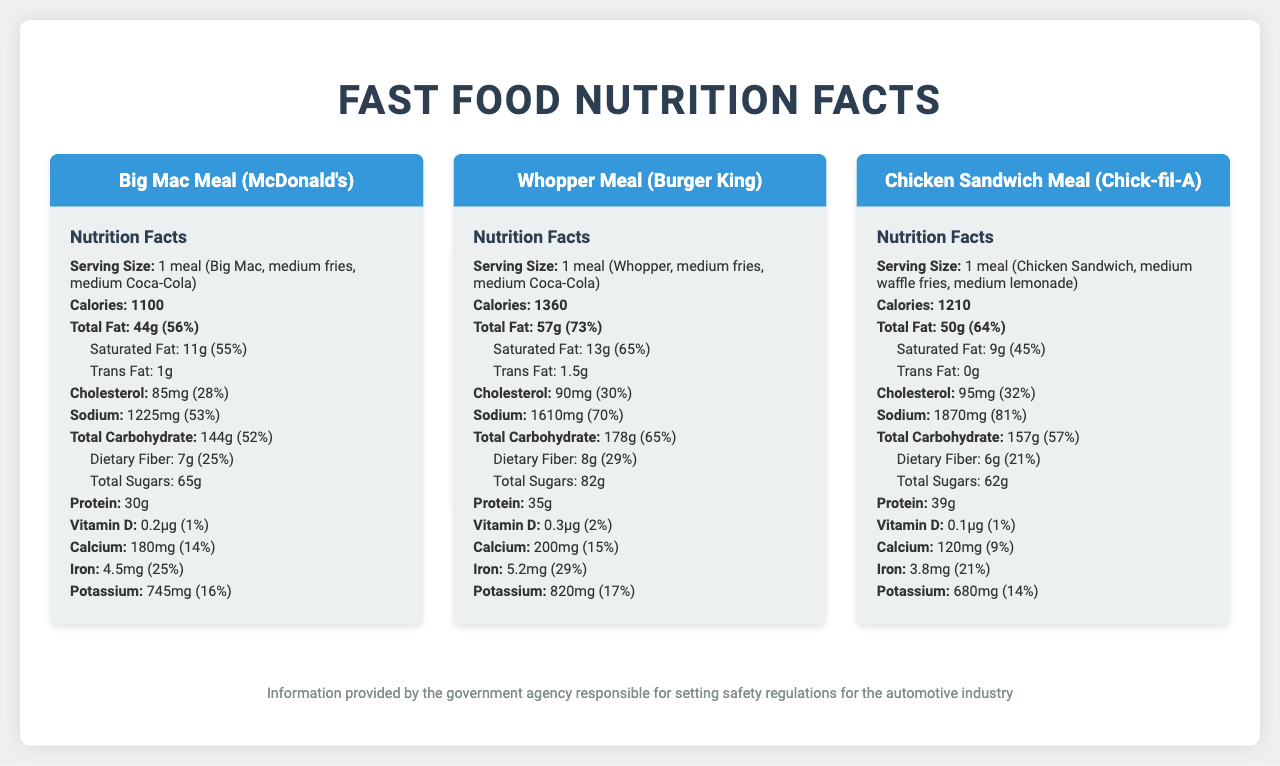what is the total calorie count for the Big Mac Meal? The document lists the calorie count for the Big Mac Meal as 1100 calories under the "Calories" section.
Answer: 1100 calories which meal has the highest total fat content? A. Big Mac Meal B. Whopper Meal C. Chicken Sandwich Meal The Whopper Meal has the highest total fat content of 57 grams, as stated in the document under the “Total Fat” section.
Answer: B what is the daily value percentage of saturated fat in the Chicken Sandwich Meal? The document specifies that the Chicken Sandwich Meal contains 9 grams of saturated fat, which is 45% of the daily value.
Answer: 45% how much dietary fiber is in the Whopper Meal? The document states that the Whopper Meal contains 8 grams of dietary fiber.
Answer: 8 grams which meal provides the most protein? According to the document, the Chicken Sandwich Meal provides 39 grams of protein, the highest among the listed meals.
Answer: Chicken Sandwich Meal how much calcium is provided by the Big Mac Meal? The document indicates that the Big Mac Meal contains 180 milligrams of calcium.
Answer: 180 mg does the document include information about organic ingredients? There is no mention or indication of organic ingredients in the document.
Answer: No summarize the main nutritional concerns for the meals listed in the document The document focuses on the nutritional breakdown of popular fast-food meals, highlighting high calorie counts, high sodium levels, and significant amounts of total fat and saturated fat.
Answer: High calories, high sodium, and significant total and saturated fat content compare the sodium content in the Big Mac Meal and the Chicken Sandwich Meal The Chicken Sandwich Meal contains 1870 milligrams of sodium compared to 1225 milligrams in the Big Mac Meal.
Answer: Chicken Sandwich Meal has more sodium which fast food meal has the highest sugar content? A. Big Mac Meal B. Whopper Meal C. Chicken Sandwich Meal D. Not enough information The Whopper Meal has the highest sugar content with 82 grams, according to the document.
Answer: B how many grams of trans fat are in the Whopper Meal? The document lists 1.5 grams of trans fat for the Whopper Meal under the “Trans Fat” section.
Answer: 1.5 grams how does the vitamin D content compare among the meals? The Whopper Meal provides 0.3 micrograms of vitamin D, more than the Big Mac Meal (0.2 micrograms) and the Chicken Sandwich Meal (0.1 micrograms).
Answer: Whopper Meal has the most vitamin D with 0.3 micrograms what regulatory consideration is specifically related to sodium in fast food meals? The document mentions "sodium reduction initiatives" as part of the regulatory considerations.
Answer: Sodium reduction initiatives what is the serving size of the Chicken Sandwich Meal? The serving size of the Chicken Sandwich Meal is specified in the document as one meal comprising a Chicken Sandwich, medium waffle fries, and medium lemonade.
Answer: 1 meal (Chicken Sandwich, medium waffle fries, medium lemonade) which meal has a cholesterol content closest to 30% of the daily value? The Whopper Meal has a cholesterol content closest to 30% of the daily value, with the document listing it at 30%.
Answer: Whopper Meal why are calorie disclosures mandated for fast-food chains? The document mentions that calorie disclosures are essential to comply with the FDA's Menu Labeling Rule, making it easier for consumers to make informed choices.
Answer: To ensure compliance with the FDA’s Menu Labeling Rule 